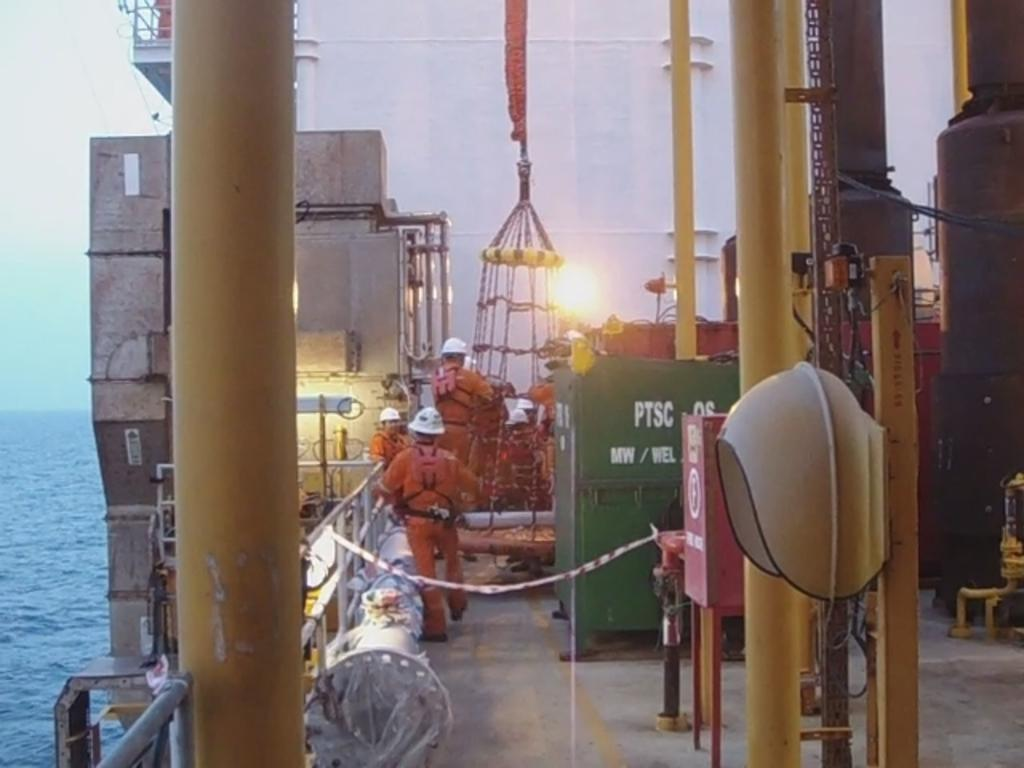What is the main subject of the image? The image depicts a ship. What specific features can be seen on the ship? There are poles, boxes, railings, and people wearing helmets on the ship. What is visible in the background of the image? There is water visible in the background of the image. What type of sweater is the person wearing in the image? There are no people wearing sweaters in the image; they are wearing helmets. Can you tell me where the cellar is located on the ship? There is no mention of a cellar in the image; it only shows the exterior of the ship. 